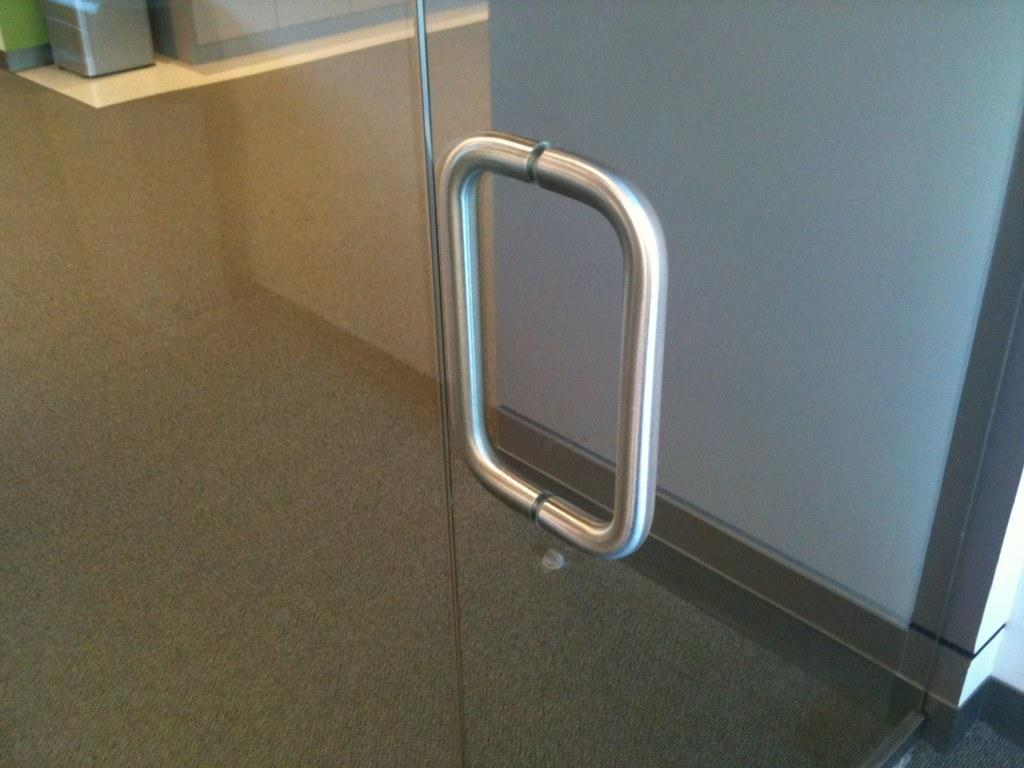What is located in the foreground of the image? There is a glass door in the foreground of the image. What is the material of the handle on the glass door? The glass door has a metal handle. What can be seen in the background of the image? There is an object on a table in the background of the image. How does the spy use the glass door to infiltrate the building in the image? There is no spy present in the image, and the glass door is not being used for infiltration purposes. 